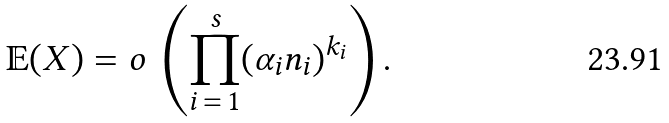Convert formula to latex. <formula><loc_0><loc_0><loc_500><loc_500>\mathbb { E } ( X ) = o \, \left ( \prod _ { i \, = \, 1 } ^ { s } ( \alpha _ { i } n _ { i } ) ^ { k _ { i } } \right ) .</formula> 